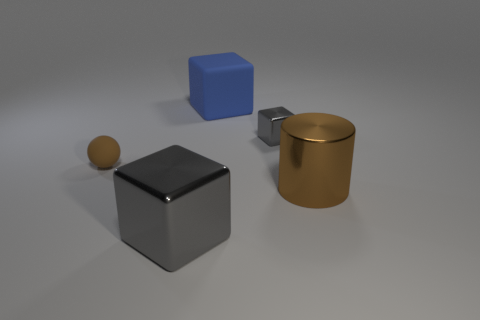Is there any other thing that is the same shape as the large brown thing?
Provide a succinct answer. No. Do the object in front of the brown cylinder and the ball have the same material?
Keep it short and to the point. No. What material is the blue cube that is the same size as the brown metallic object?
Make the answer very short. Rubber. What number of other objects are there of the same material as the ball?
Offer a very short reply. 1. There is a brown rubber thing; is it the same size as the brown thing to the right of the big matte cube?
Provide a short and direct response. No. Is the number of gray metallic objects that are to the right of the large gray metallic object less than the number of big blocks on the left side of the big brown shiny cylinder?
Offer a very short reply. Yes. What is the size of the brown thing that is on the left side of the tiny shiny cube?
Make the answer very short. Small. Do the blue rubber block and the shiny cylinder have the same size?
Give a very brief answer. Yes. How many things are both to the right of the small sphere and left of the blue rubber cube?
Offer a very short reply. 1. How many red objects are either small metal things or large cubes?
Keep it short and to the point. 0. 